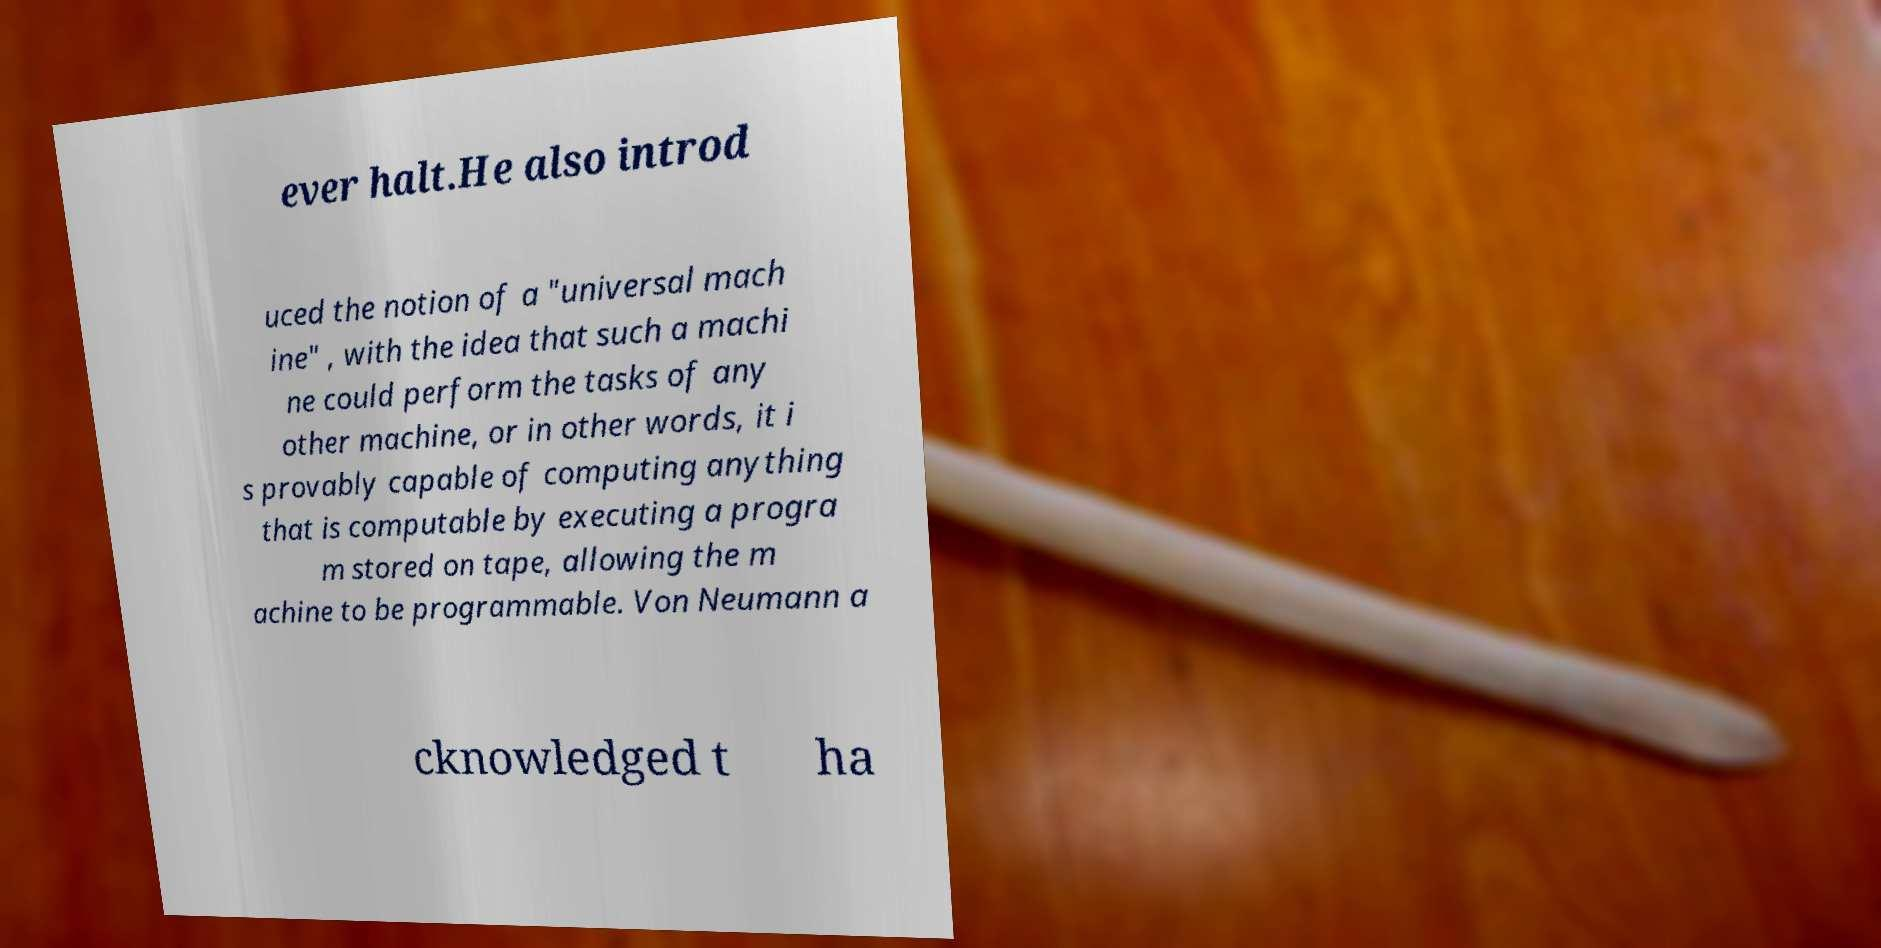I need the written content from this picture converted into text. Can you do that? ever halt.He also introd uced the notion of a "universal mach ine" , with the idea that such a machi ne could perform the tasks of any other machine, or in other words, it i s provably capable of computing anything that is computable by executing a progra m stored on tape, allowing the m achine to be programmable. Von Neumann a cknowledged t ha 